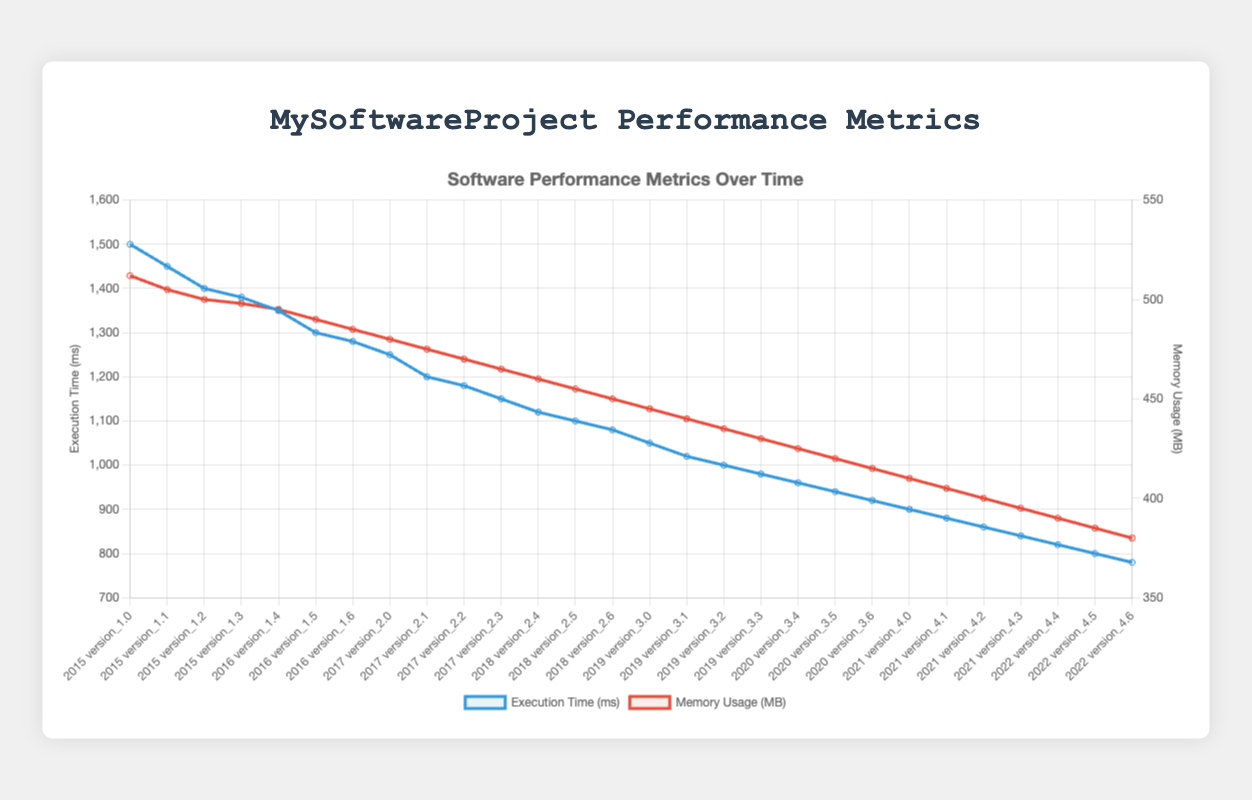What's the trend in execution time from 2015 to 2022? The trend in execution time from 2015 to 2022 shows a clear and consistent decrease over the years as indicated by the downward slope of the blue line. Each version update results in lower execution times.
Answer: Decreasing Which year had the greatest improvement in execution time when comparing the earliest and the latest versions of that year? To identify the greatest improvement, we compare the earliest and latest execution times each year. The greatest difference is in 2021, where execution time improved from 900 ms (version 4.0) to 840 ms (version 4.3), an improvement of 60 ms.
Answer: 2021 In which year did memory usage first drop below 450 MB? By examining the memory usage trend (red line), we see that in 2019, the memory usage first dropped below 450 MB with version 3.3 at 430 MB.
Answer: 2019 How does the execution time of version 2.0 in 2017 compare to the execution time of version 4.3 in 2021? Execution time for version 2.0 in 2017 is 1250 ms. For version 4.3 in 2021, it is 840 ms. Comparing these, version 4.3 is significantly faster with a difference of 410 ms.
Answer: 840 ms is faster Which version had the lowest memory usage across all years? To find the lowest memory usage, inspect the graph's red line for the lowest point. The lowest memory usage value is in version 4.6 in 2022 with 380 MB.
Answer: Version 4.6 (2022) What is the overall average execution time improvement per year from 2015 to 2022? Compute the execution improvement from the first to the last version each year and average these values:
2015: (1500-1380) = 120, 
2016: (1350-1280) = 70, 
2017: (1250-1150) = 100, 
2018: (1120-1080) = 40, 
2019: (1050-980) = 70, 
2020: (960-920) = 40, 
2021: (900-840) = 60, 
2022: (820-780) = 40.
Average = (120 + 70 + 100 + 40 + 70 + 40 + 60 + 40) / 8 = 67.5
Answer: 67.5 ms per year Does memory usage show a stronger improvement trend than execution time over the years? Both memory usage and execution time improve over the years. However, the execution time (blue line) shows a steeper decline compared to the memory usage (red line), indicating a stronger improvement in execution time.
Answer: Execution time Between 2015 and 2019, which year saw the smallest memory usage reduction? Calculate the reductions each year:
2015: (512-498) = 14,
2016: (495-485) = 10,
2017: (480-465) = 15,
2018: (460-450) = 10,
2019: (445-430) = 15.
Smallest reduction = 10 MB in 2016 and 2018.
Answer: 2016 and 2018 What are the execution times for versions that marked the end of a major series (e.g., 1.3, 2.3, 3.3, 4.3)? Extract the execution times for the last versions of each major series:
Version 1.3: 1380 ms,
Version 2.3: 1150 ms,
Version 3.3: 980 ms,
Version 4.3: 840 ms.
Answer: 1380 ms, 1150 ms, 980 ms, 840 ms 